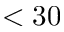<formula> <loc_0><loc_0><loc_500><loc_500>< 3 0</formula> 